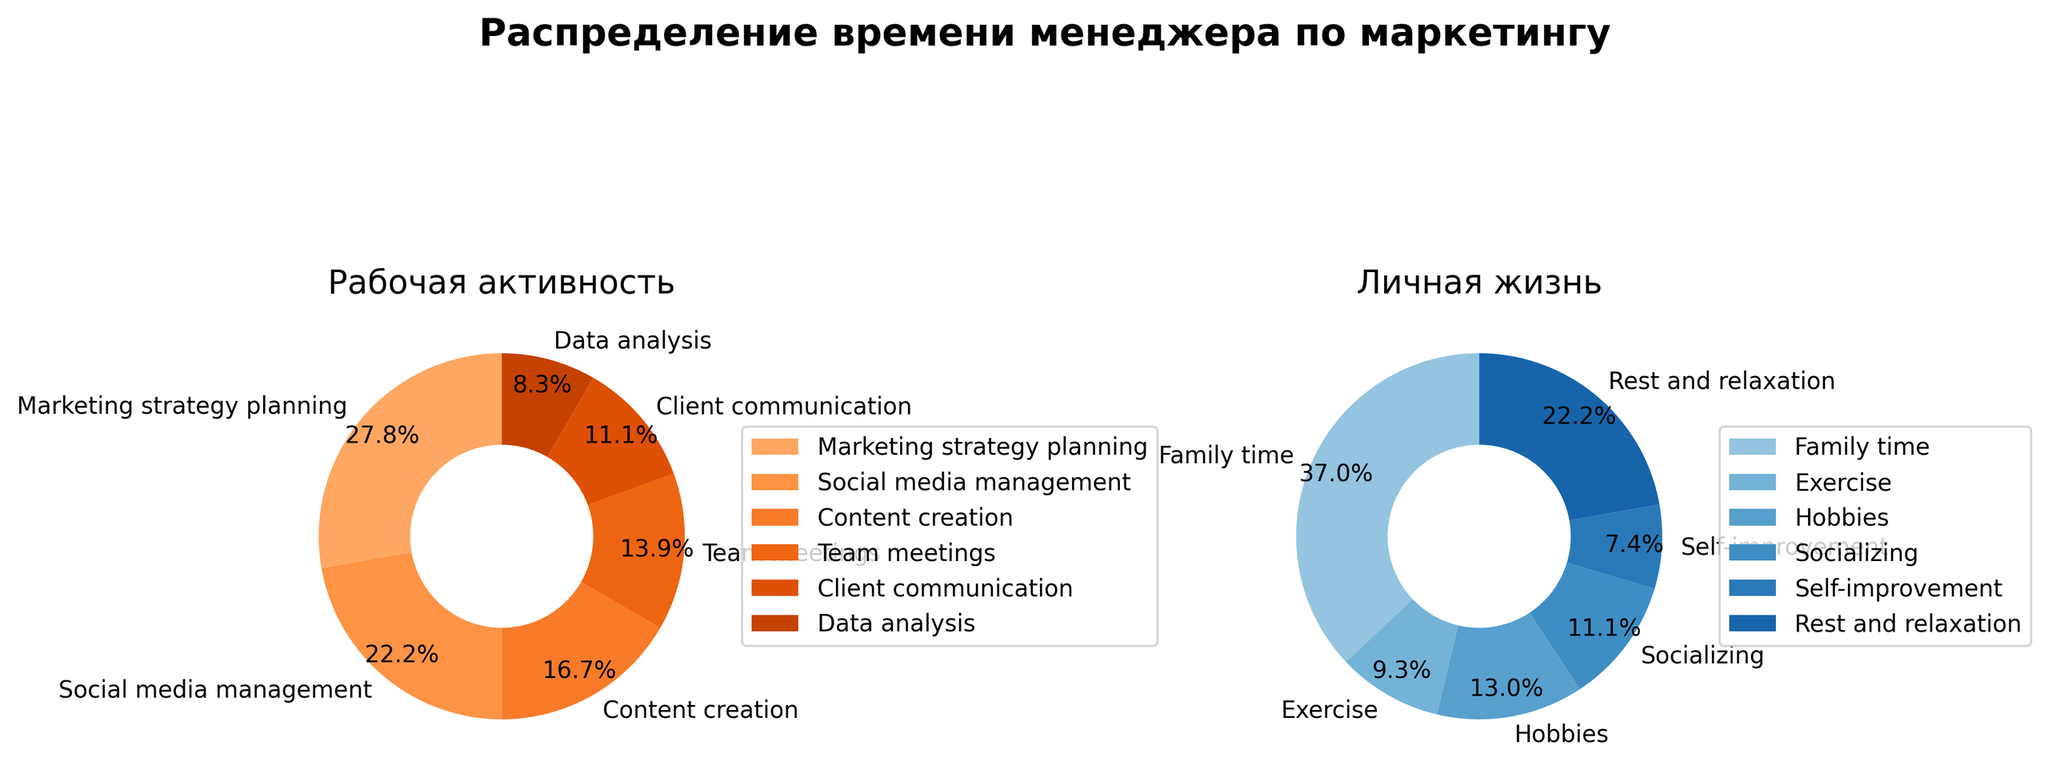What is the title of the figure? The title is located at the top of the figure in bold font. It provides an overview of the figure's content. The title is "Распределение времени менеджера по маркетингу".
Answer: Распределение времени менеджера по маркетингу Which work-related activity takes up the most time per week? Look at the left pie chart labeled "Рабочая активность" and identify the biggest segment. The largest segment is labeled "Marketing strategy planning".
Answer: Marketing strategy planning What percentage of time is spent on "Family time"? Look at the right pie chart labeled "Личная жизнь" and find the segment for "Family time". The percentage is displayed within the segment. The segment shows 34.5%.
Answer: 34.5% How many hours per week are spent on content creation? Refer to the left pie chart labeled "Рабочая активность". Locate the "Content creation" segment and identify the corresponding number of hours, which is 6.
Answer: 6 What activity under "Личная жизнь" has a similar percentage to "Team meetings" under "Рабочая активность"? Compare the segments in both pie charts. "Team meetings" in "Рабочая активность" shows 17.2%. In "Личная жизнь", "Hobbies" has a percentage close to 12.1%.
Answer: Hobbies What’s the total number of hours spent on "Рабочая активность" per week? Add up the hours of all activities under "Рабочая активность": 10 (Marketing strategy planning) + 8 (Social media management) + 6 (Content creation) + 5 (Team meetings) + 4 (Client communication) + 3 (Data analysis) = 36 hours.
Answer: 36 Compare the time spent on "Exercise" and "Social media management". Which one takes more hours per week? Look at both pie charts. "Exercise" under "Личная жизнь" takes 5 hours per week while "Social media management" under "Рабочая активность" takes 8 hours per week. Thus, "Social media management" takes more time.
Answer: Social media management Which activity under "Личная жизнь" occupies the smallest segment of the pie chart and how many hours does it account for? Look at the right pie chart. The smallest segment is for "Self-improvement", which accounts for 4 hours per week.
Answer: Self-improvement, 4 